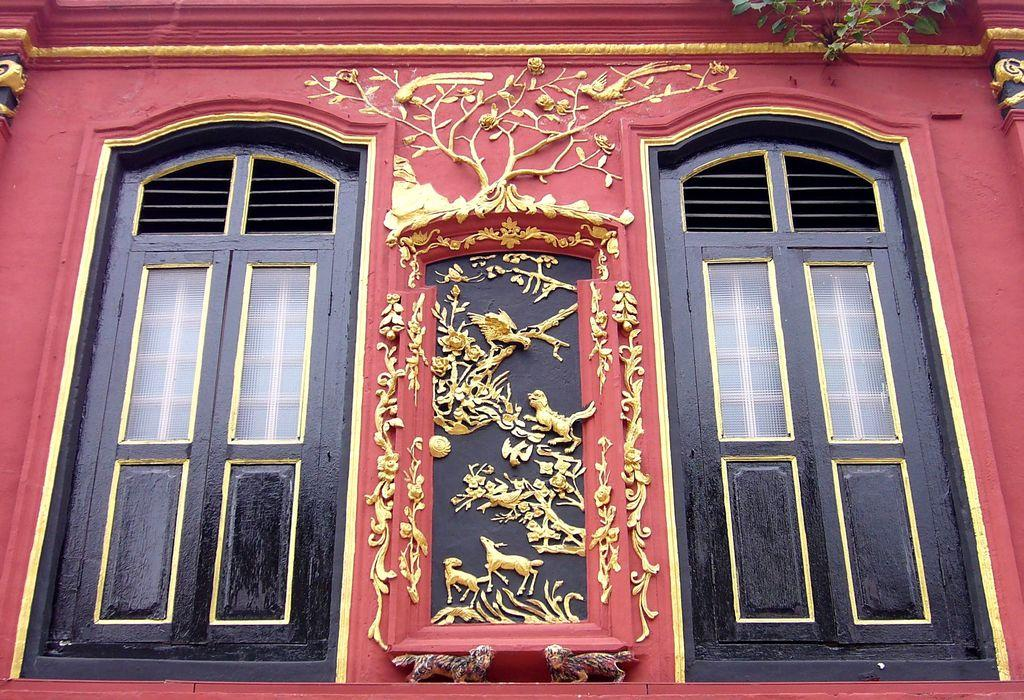Where was the image taken? The image was taken outdoors. What can be seen on the wall in the image? There is a wall with carvings in the image. How many doors are visible in the image? There are two doors in the image. What type of mice can be seen eating popcorn in the image? There are no mice or popcorn present in the image. 